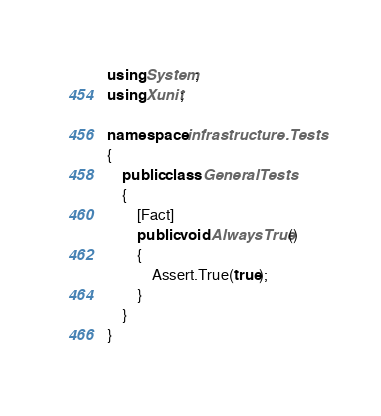<code> <loc_0><loc_0><loc_500><loc_500><_C#_>using System;
using Xunit;

namespace infrastructure.Tests
{
    public class GeneralTests
    {
        [Fact]
        public void AlwaysTrue()
        {
            Assert.True(true);
        }
    }
}
</code> 